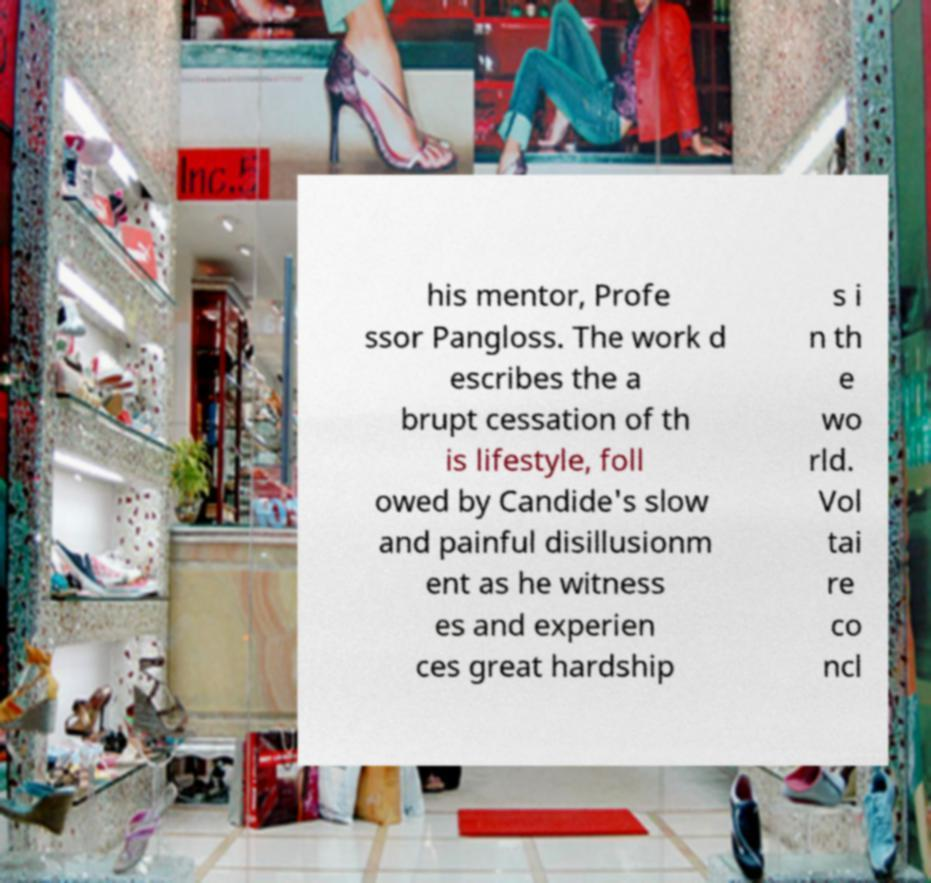Could you extract and type out the text from this image? his mentor, Profe ssor Pangloss. The work d escribes the a brupt cessation of th is lifestyle, foll owed by Candide's slow and painful disillusionm ent as he witness es and experien ces great hardship s i n th e wo rld. Vol tai re co ncl 